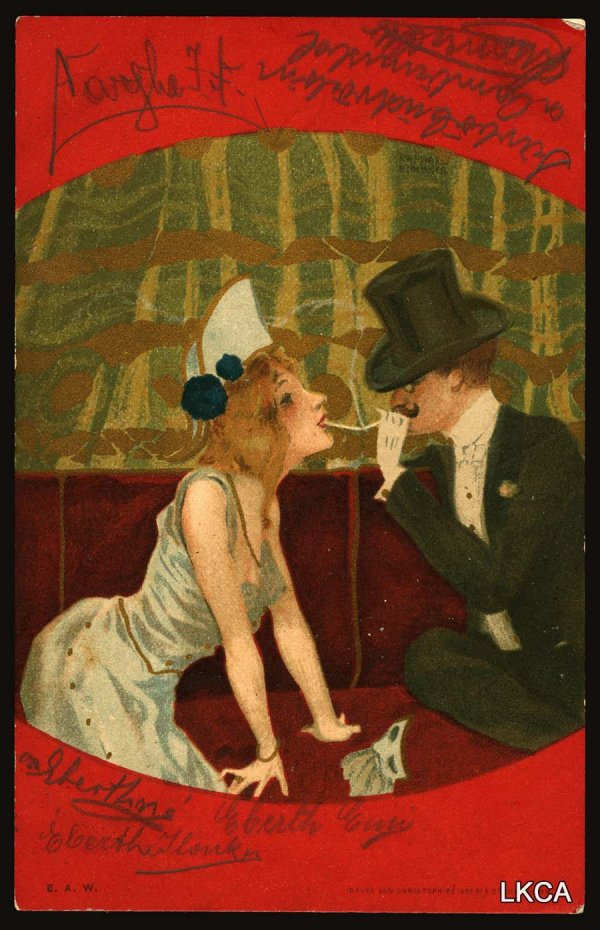What is this photo about'? The image portrays a man and a woman in a romantic setting, evoking the artistic sensibilities of the early 20th century. The man, donning a top hat, and the woman, adorned in a white dress with a blue hat, share an intimate moment as they lean towards each other on a red couch. The backdrop is a vibrant green pattern, contrasting with the bold colors of their attire and the couch. The strong lines and vivid colors hint at an art style reminiscent of post-impressionism or art nouveau. A German phrase "Lang lebe die Liebe, Mögen alle Herzen glühen," meaning "Long live love, may all hearts glow," adds a poetic touch to the scene. The initials "E.A.W." are visible, possibly indicating the artist's signature. 